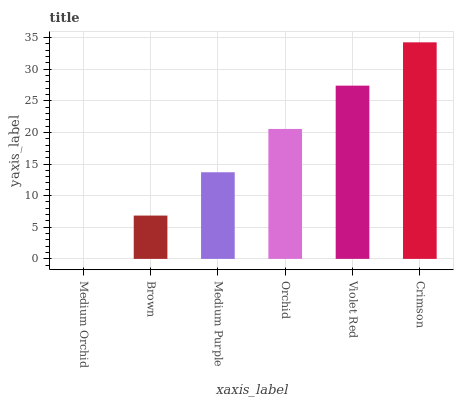Is Medium Orchid the minimum?
Answer yes or no. Yes. Is Crimson the maximum?
Answer yes or no. Yes. Is Brown the minimum?
Answer yes or no. No. Is Brown the maximum?
Answer yes or no. No. Is Brown greater than Medium Orchid?
Answer yes or no. Yes. Is Medium Orchid less than Brown?
Answer yes or no. Yes. Is Medium Orchid greater than Brown?
Answer yes or no. No. Is Brown less than Medium Orchid?
Answer yes or no. No. Is Orchid the high median?
Answer yes or no. Yes. Is Medium Purple the low median?
Answer yes or no. Yes. Is Violet Red the high median?
Answer yes or no. No. Is Crimson the low median?
Answer yes or no. No. 